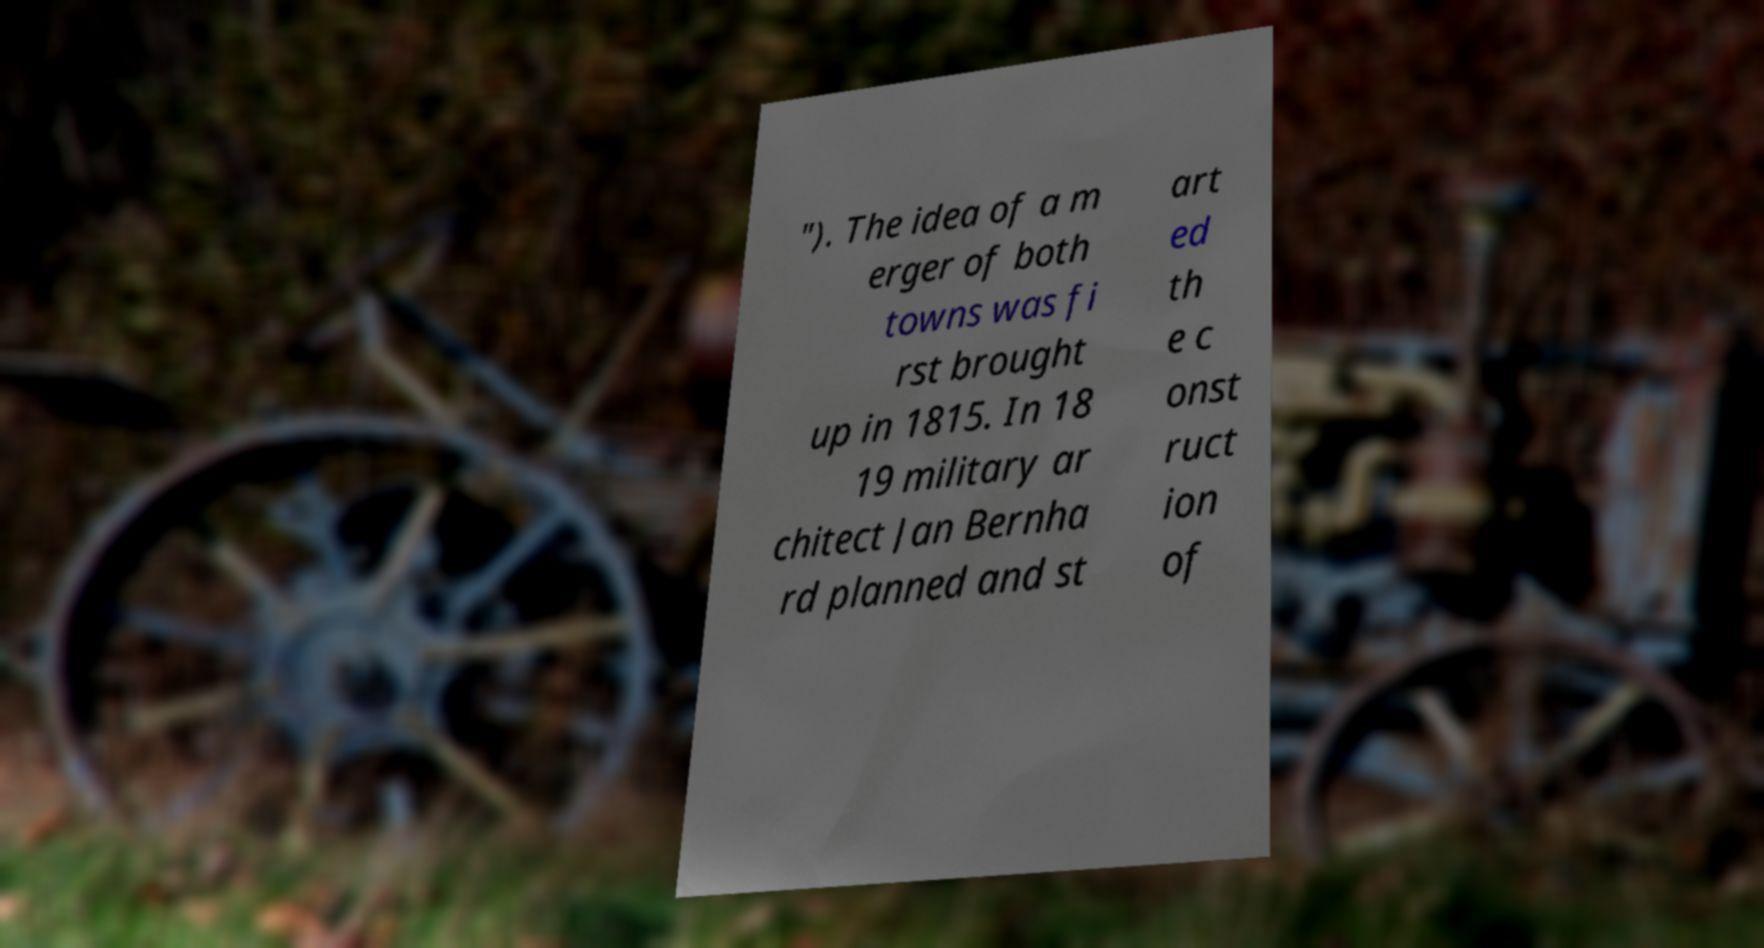Can you accurately transcribe the text from the provided image for me? "). The idea of a m erger of both towns was fi rst brought up in 1815. In 18 19 military ar chitect Jan Bernha rd planned and st art ed th e c onst ruct ion of 